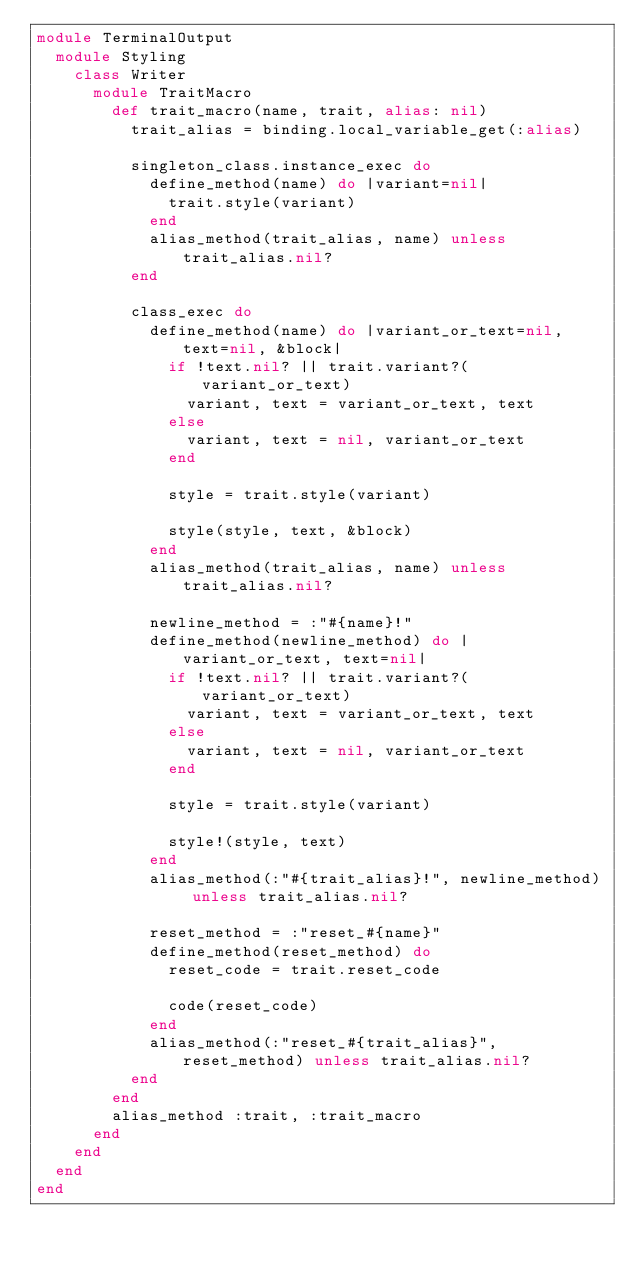<code> <loc_0><loc_0><loc_500><loc_500><_Ruby_>module TerminalOutput
  module Styling
    class Writer
      module TraitMacro
        def trait_macro(name, trait, alias: nil)
          trait_alias = binding.local_variable_get(:alias)

          singleton_class.instance_exec do
            define_method(name) do |variant=nil|
              trait.style(variant)
            end
            alias_method(trait_alias, name) unless trait_alias.nil?
          end

          class_exec do
            define_method(name) do |variant_or_text=nil, text=nil, &block|
              if !text.nil? || trait.variant?(variant_or_text)
                variant, text = variant_or_text, text
              else
                variant, text = nil, variant_or_text
              end

              style = trait.style(variant)

              style(style, text, &block)
            end
            alias_method(trait_alias, name) unless trait_alias.nil?

            newline_method = :"#{name}!"
            define_method(newline_method) do |variant_or_text, text=nil|
              if !text.nil? || trait.variant?(variant_or_text)
                variant, text = variant_or_text, text
              else
                variant, text = nil, variant_or_text
              end

              style = trait.style(variant)

              style!(style, text)
            end
            alias_method(:"#{trait_alias}!", newline_method) unless trait_alias.nil?

            reset_method = :"reset_#{name}"
            define_method(reset_method) do
              reset_code = trait.reset_code

              code(reset_code)
            end
            alias_method(:"reset_#{trait_alias}", reset_method) unless trait_alias.nil?
          end
        end
        alias_method :trait, :trait_macro
      end
    end
  end
end
</code> 